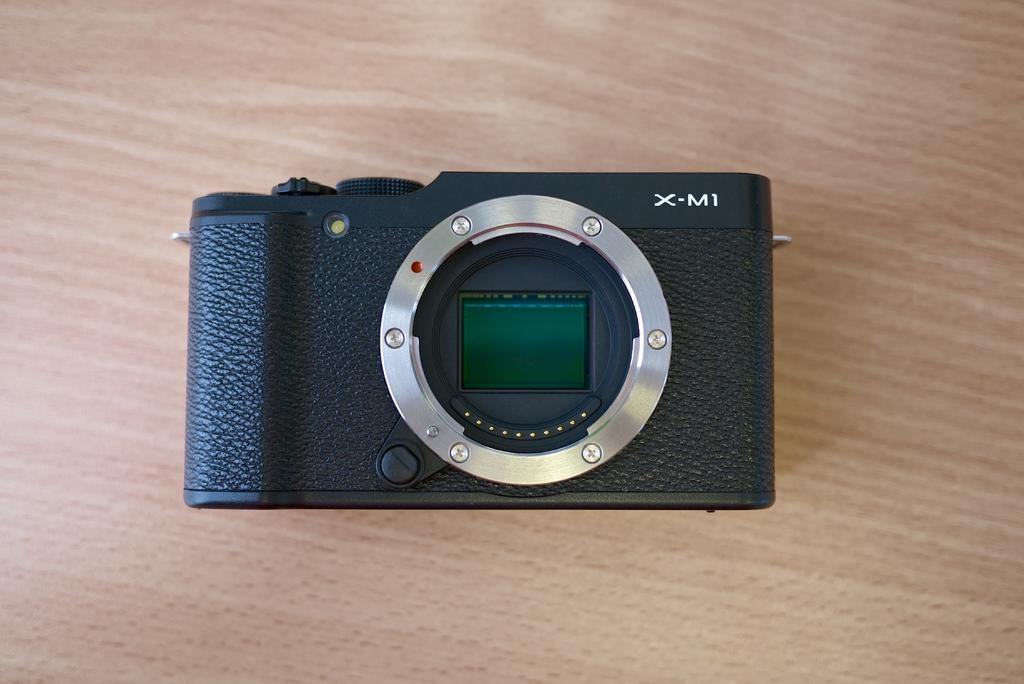What object is the main focus of the picture? The main focus of the picture is a camera. Where is the camera placed in the image? The camera is placed on a wooden table. What is the color of the camera? The camera is black in color. How many kettles are visible under the table in the image? There are no kettles visible in the image, and none are mentioned as being under the table. 